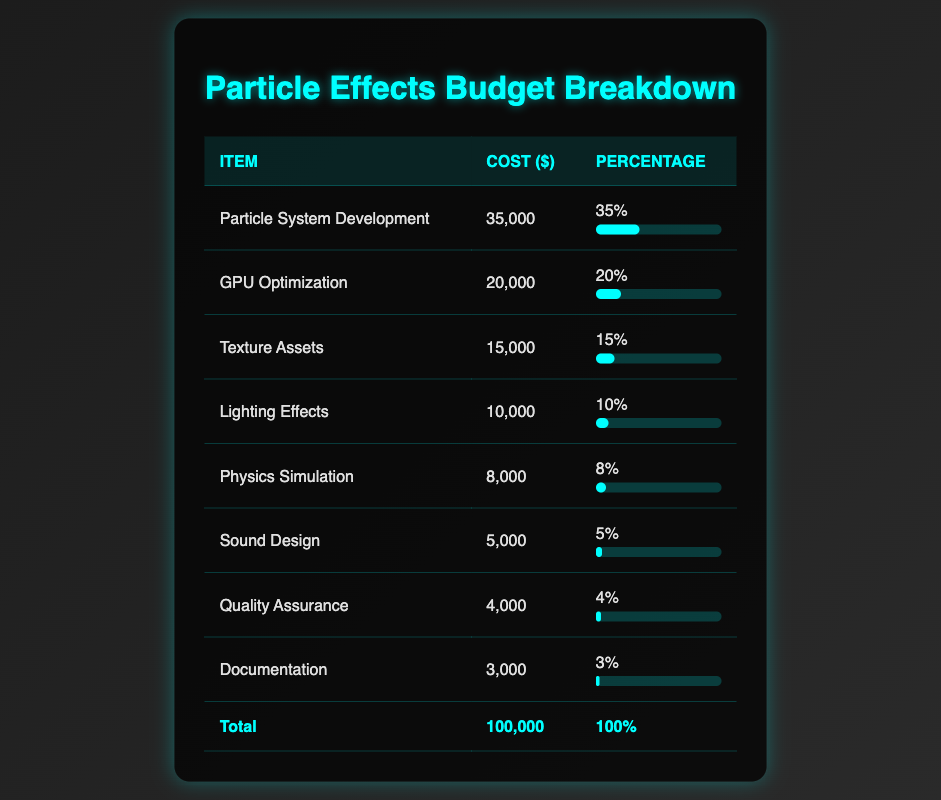What is the total cost of all items in the budget? The total cost is listed in the footer of the table as $100,000.
Answer: 100000 Which item has the highest cost? The item with the highest cost is "Particle System Development" at $35,000.
Answer: Particle System Development What percentage of the budget is allocated to Sound Design? The percentage for Sound Design is specified as 5%.
Answer: 5% What is the combined cost of GPU Optimization and Physics Simulation? The cost of GPU Optimization is $20,000 and Physics Simulation is $8,000. Adding these gives $20,000 + $8,000 = $28,000.
Answer: 28000 Is the cost of Documentation less than the cost of Quality Assurance? Documentation costs $3,000 and Quality Assurance costs $4,000. Since $3,000 < $4,000, the statement is true.
Answer: Yes What is the average cost of the items listed? To find the average, sum all costs: $35,000 + $20,000 + $15,000 + $10,000 + $8,000 + $5,000 + $4,000 + $3,000 = $100,000. There are 8 items, so average cost is $100,000 / 8 = $12,500.
Answer: 12500 Which item takes up a larger share of the budget: Texture Assets or Lighting Effects? Texture Assets account for 15% of the budget while Lighting Effects account for 10%. Since 15% > 10%, Texture Assets take a larger share.
Answer: Texture Assets What is the total percentage of budget allocated to the top three highest cost items? The top three items are Particle System Development (35%), GPU Optimization (20%), and Texture Assets (15%). The total percentage is 35% + 20% + 15% = 70%.
Answer: 70 How much does the total budget exceed the cost of Quality Assurance? Quality Assurance costs $4,000, and the total budget is $100,000. The difference is $100,000 - $4,000 = $96,000.
Answer: 96000 